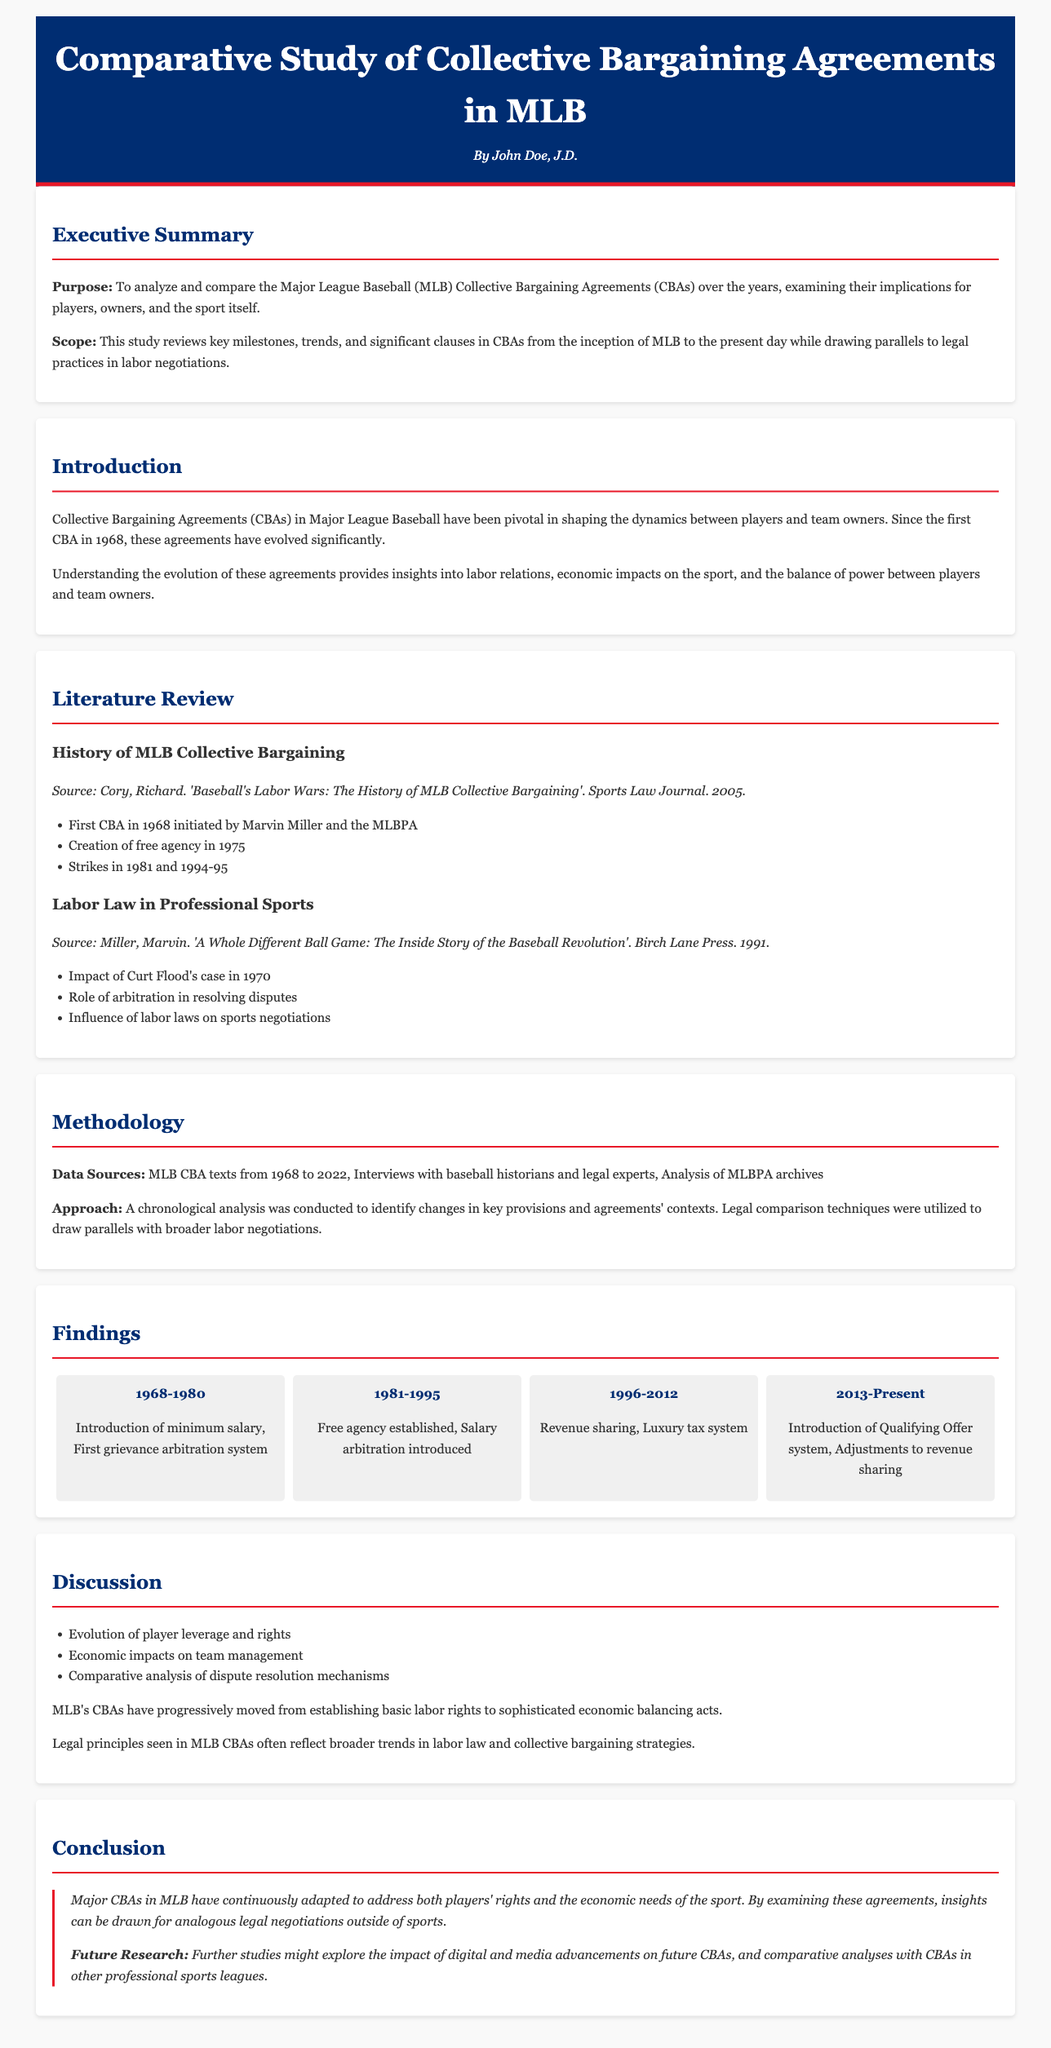What year was the first CBA established? The document states that the first CBA was established in 1968.
Answer: 1968 Who initiated the first CBA? The document notes that Marvin Miller and the MLBPA were instrumental in initiating the first CBA.
Answer: Marvin Miller What significant system was established in 1975? The document indicates that free agency was created in 1975.
Answer: Free agency What economic mechanism was introduced in the 1996-2012 period? The document mentions that revenue sharing was introduced between 1996 and 2012.
Answer: Revenue sharing How many main CBA periods are highlighted in the findings? The findings highlight four main CBA periods.
Answer: Four What is the primary focus of the conclusion section? The conclusion section focuses on the adaptation of Major CBAs to address players' rights and economic needs.
Answer: Players' rights and economic needs What tool was introduced to handle player disputes? The document states that a grievance arbitration system was introduced during the first period (1968-1980).
Answer: Grievance arbitration system What does the document propose for future research? The future research proposed in the conclusion focuses on the impact of digital advancements on CBAs and comparisons with other leagues.
Answer: Impact of digital advancements What was the focus of the discussion section? The discussion section focuses on player leverage evolution, economic impacts, and dispute resolution mechanisms.
Answer: Player leverage evolution, economic impacts, and dispute resolution mechanisms 